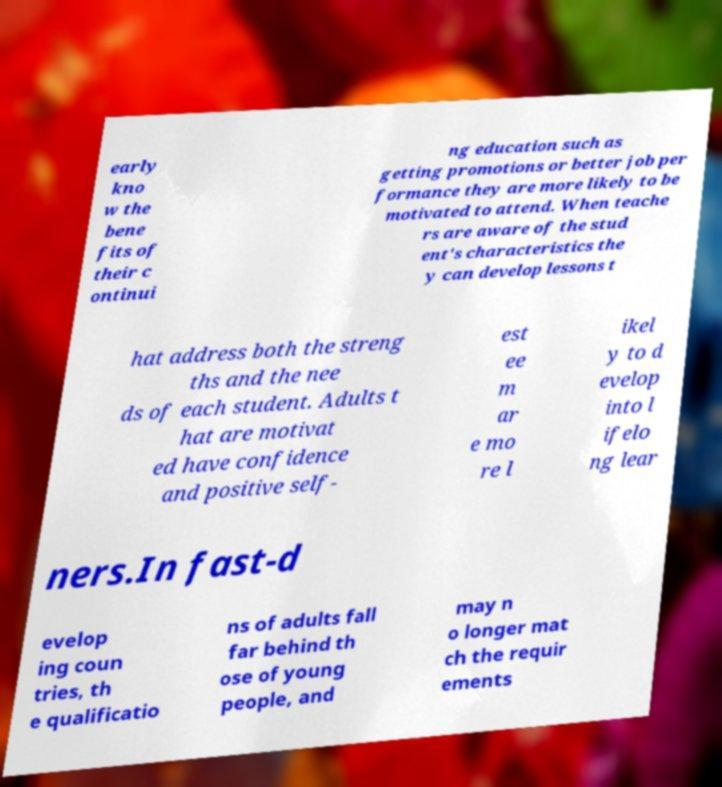Please read and relay the text visible in this image. What does it say? early kno w the bene fits of their c ontinui ng education such as getting promotions or better job per formance they are more likely to be motivated to attend. When teache rs are aware of the stud ent's characteristics the y can develop lessons t hat address both the streng ths and the nee ds of each student. Adults t hat are motivat ed have confidence and positive self- est ee m ar e mo re l ikel y to d evelop into l ifelo ng lear ners.In fast-d evelop ing coun tries, th e qualificatio ns of adults fall far behind th ose of young people, and may n o longer mat ch the requir ements 